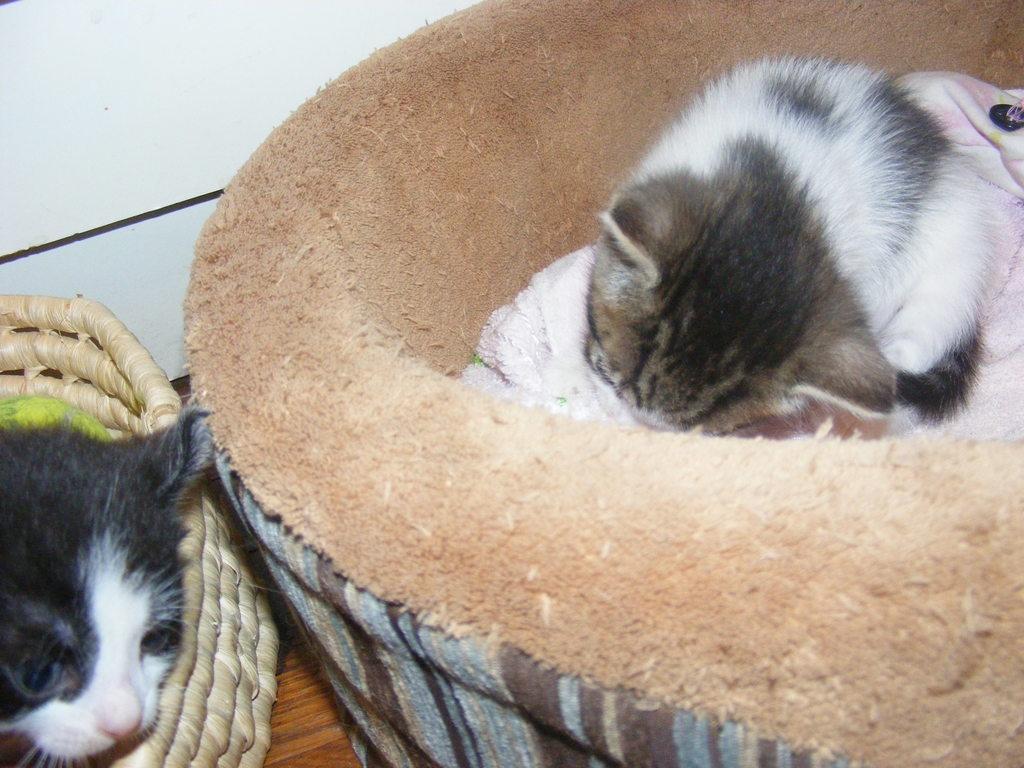How would you summarize this image in a sentence or two? In this image we can see two cats in pet beds and in the background we can see the sky. 